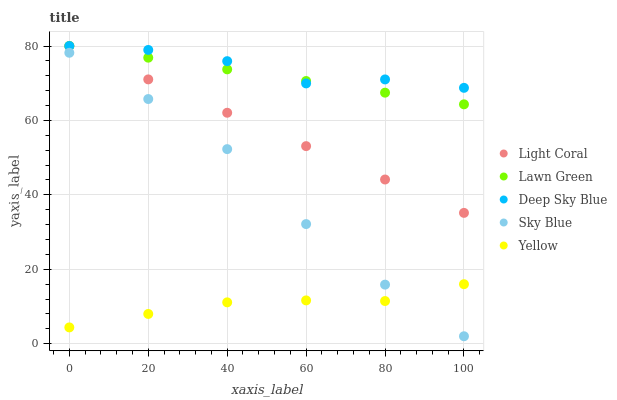Does Yellow have the minimum area under the curve?
Answer yes or no. Yes. Does Deep Sky Blue have the maximum area under the curve?
Answer yes or no. Yes. Does Lawn Green have the minimum area under the curve?
Answer yes or no. No. Does Lawn Green have the maximum area under the curve?
Answer yes or no. No. Is Lawn Green the smoothest?
Answer yes or no. Yes. Is Deep Sky Blue the roughest?
Answer yes or no. Yes. Is Yellow the smoothest?
Answer yes or no. No. Is Yellow the roughest?
Answer yes or no. No. Does Sky Blue have the lowest value?
Answer yes or no. Yes. Does Lawn Green have the lowest value?
Answer yes or no. No. Does Deep Sky Blue have the highest value?
Answer yes or no. Yes. Does Yellow have the highest value?
Answer yes or no. No. Is Sky Blue less than Light Coral?
Answer yes or no. Yes. Is Lawn Green greater than Sky Blue?
Answer yes or no. Yes. Does Light Coral intersect Deep Sky Blue?
Answer yes or no. Yes. Is Light Coral less than Deep Sky Blue?
Answer yes or no. No. Is Light Coral greater than Deep Sky Blue?
Answer yes or no. No. Does Sky Blue intersect Light Coral?
Answer yes or no. No. 